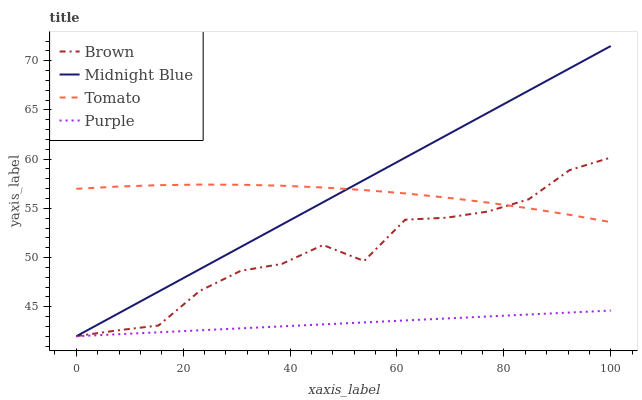Does Purple have the minimum area under the curve?
Answer yes or no. Yes. Does Midnight Blue have the maximum area under the curve?
Answer yes or no. Yes. Does Brown have the minimum area under the curve?
Answer yes or no. No. Does Brown have the maximum area under the curve?
Answer yes or no. No. Is Midnight Blue the smoothest?
Answer yes or no. Yes. Is Brown the roughest?
Answer yes or no. Yes. Is Brown the smoothest?
Answer yes or no. No. Is Midnight Blue the roughest?
Answer yes or no. No. Does Midnight Blue have the lowest value?
Answer yes or no. Yes. Does Brown have the lowest value?
Answer yes or no. No. Does Midnight Blue have the highest value?
Answer yes or no. Yes. Does Brown have the highest value?
Answer yes or no. No. Is Purple less than Brown?
Answer yes or no. Yes. Is Brown greater than Purple?
Answer yes or no. Yes. Does Tomato intersect Midnight Blue?
Answer yes or no. Yes. Is Tomato less than Midnight Blue?
Answer yes or no. No. Is Tomato greater than Midnight Blue?
Answer yes or no. No. Does Purple intersect Brown?
Answer yes or no. No. 